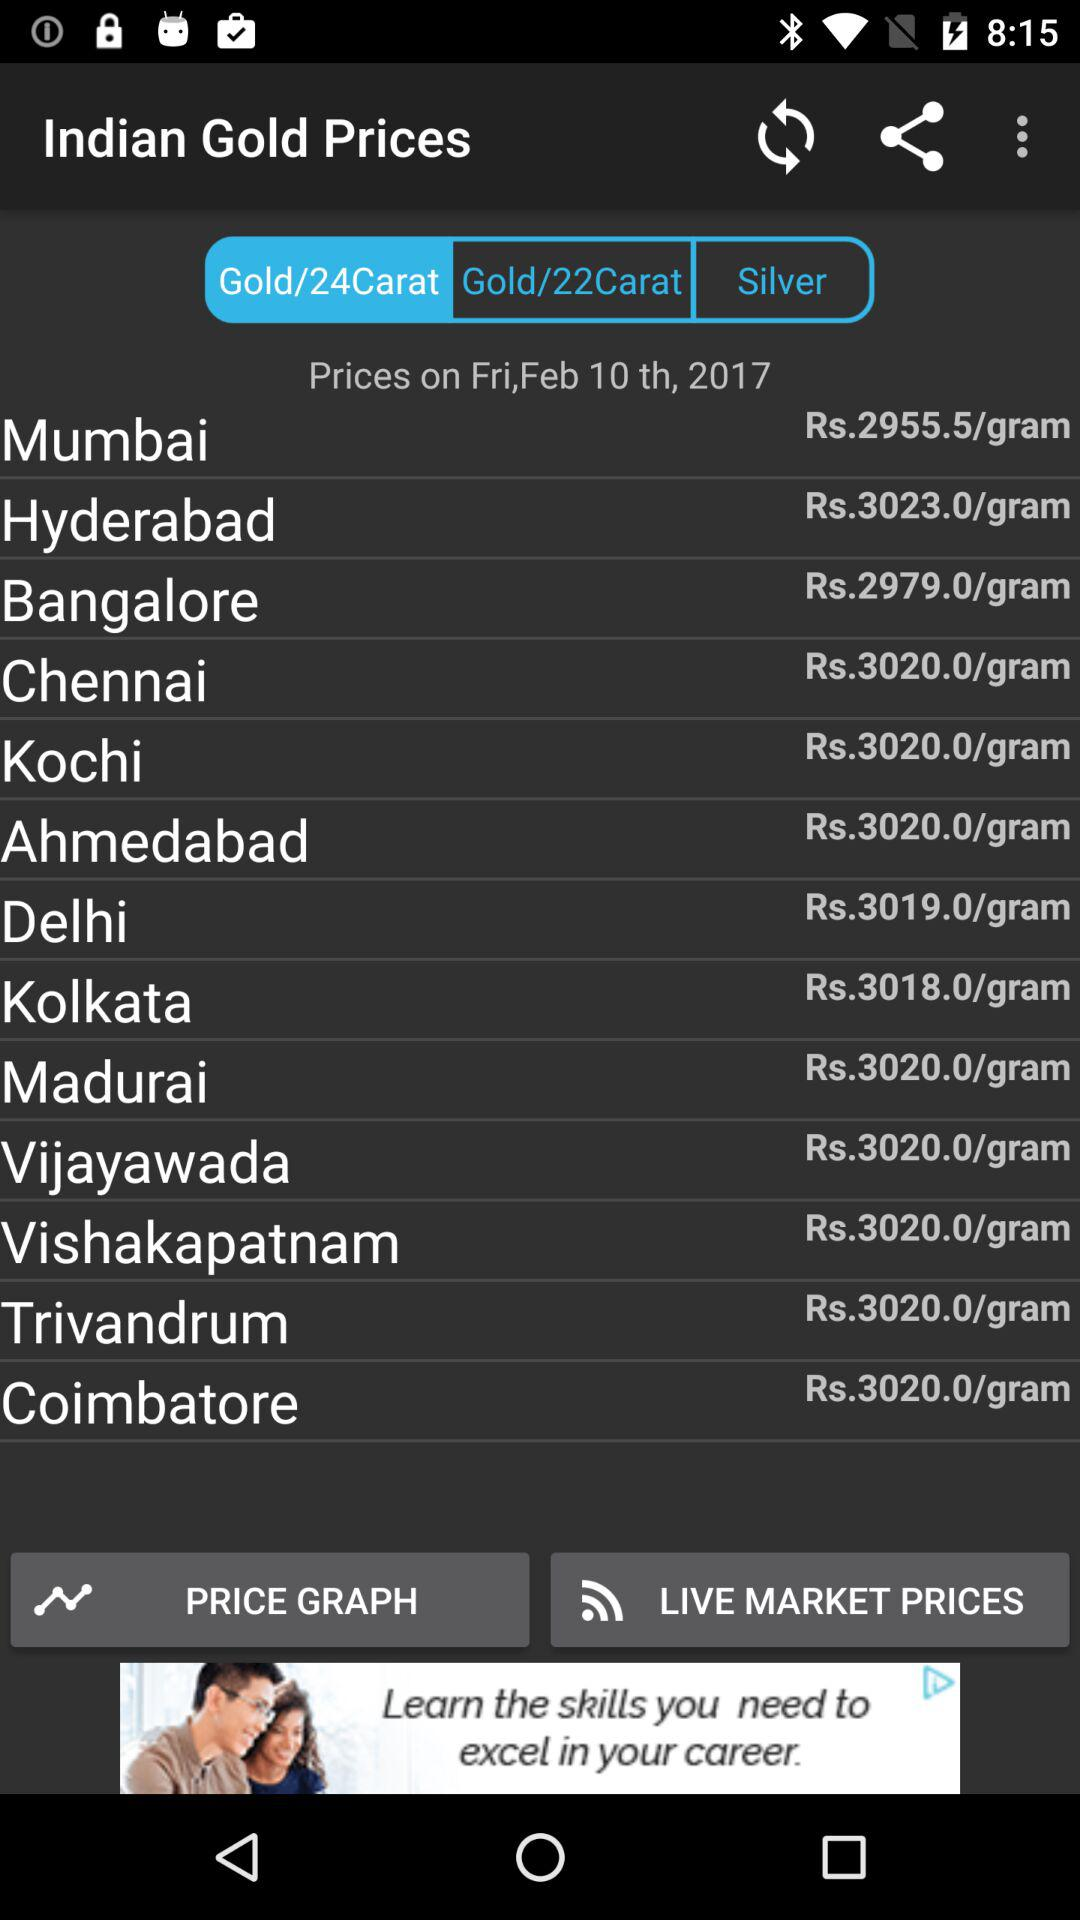What is the date of the "Indian Gold Prices"? The date of the "Indian Gold Prices" is Friday, February 10th, 2017. 